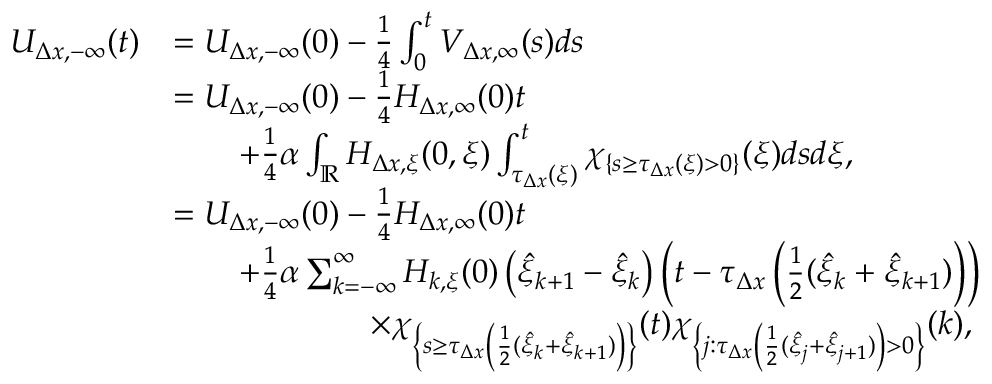Convert formula to latex. <formula><loc_0><loc_0><loc_500><loc_500>\begin{array} { r l } { U _ { \Delta x , - \infty } ( t ) } & { = U _ { \Delta x , - \infty } ( 0 ) - \frac { 1 } { 4 } \int _ { 0 } ^ { t } V _ { \Delta x , \infty } ( s ) d s } \\ & { = U _ { \Delta x , - \infty } ( 0 ) - \frac { 1 } { 4 } H _ { \Delta x , \infty } ( 0 ) t } \\ & { \quad + \frac { 1 } { 4 } \alpha \int _ { \mathbb { R } } H _ { \Delta x , \xi } ( 0 , \xi ) \int _ { \tau _ { \Delta x } ( \xi ) } ^ { t } \chi _ { \{ s \geq \tau _ { \Delta x } ( \xi ) > 0 \} } ( \xi ) d s d \xi , } \\ & { = U _ { \Delta x , - \infty } ( 0 ) - \frac { 1 } { 4 } H _ { \Delta x , \infty } ( 0 ) t } \\ & { \quad + \frac { 1 } { 4 } \alpha \sum _ { k = - \infty } ^ { \infty } H _ { k , \xi } ( 0 ) \left ( \hat { \xi } _ { k + 1 } - \hat { \xi } _ { k } \right ) \left ( t - \tau _ { \Delta x } \left ( \frac { 1 } { 2 } ( \hat { \xi } _ { k } + \hat { \xi } _ { k + 1 } ) \right ) \right ) } \\ & { \quad \times \chi _ { \left \{ s \geq \tau _ { \Delta x } \left ( \frac { 1 } { 2 } ( \hat { \xi } _ { k } + \hat { \xi } _ { k + 1 } ) \right ) \right \} } ( t ) \chi _ { \left \{ j \colon \tau _ { \Delta x } \left ( \frac { 1 } { 2 } ( \hat { \xi } _ { j } + \hat { \xi } _ { j + 1 } ) \right ) > 0 \right \} } ( k ) , } \end{array}</formula> 